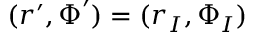Convert formula to latex. <formula><loc_0><loc_0><loc_500><loc_500>( \boldsymbol r ^ { \prime } , \boldsymbol \Phi ^ { \prime } ) = ( \boldsymbol r _ { I } , \boldsymbol \Phi _ { I } )</formula> 